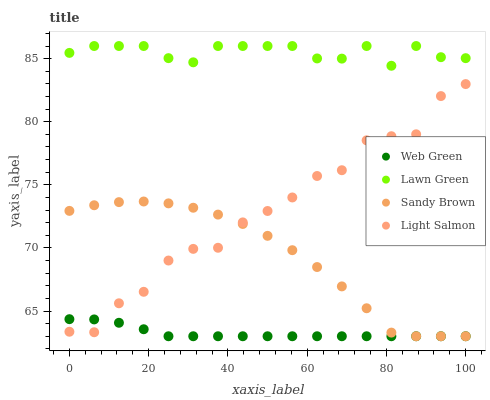Does Web Green have the minimum area under the curve?
Answer yes or no. Yes. Does Lawn Green have the maximum area under the curve?
Answer yes or no. Yes. Does Light Salmon have the minimum area under the curve?
Answer yes or no. No. Does Light Salmon have the maximum area under the curve?
Answer yes or no. No. Is Web Green the smoothest?
Answer yes or no. Yes. Is Light Salmon the roughest?
Answer yes or no. Yes. Is Sandy Brown the smoothest?
Answer yes or no. No. Is Sandy Brown the roughest?
Answer yes or no. No. Does Sandy Brown have the lowest value?
Answer yes or no. Yes. Does Light Salmon have the lowest value?
Answer yes or no. No. Does Lawn Green have the highest value?
Answer yes or no. Yes. Does Light Salmon have the highest value?
Answer yes or no. No. Is Web Green less than Lawn Green?
Answer yes or no. Yes. Is Lawn Green greater than Light Salmon?
Answer yes or no. Yes. Does Light Salmon intersect Web Green?
Answer yes or no. Yes. Is Light Salmon less than Web Green?
Answer yes or no. No. Is Light Salmon greater than Web Green?
Answer yes or no. No. Does Web Green intersect Lawn Green?
Answer yes or no. No. 